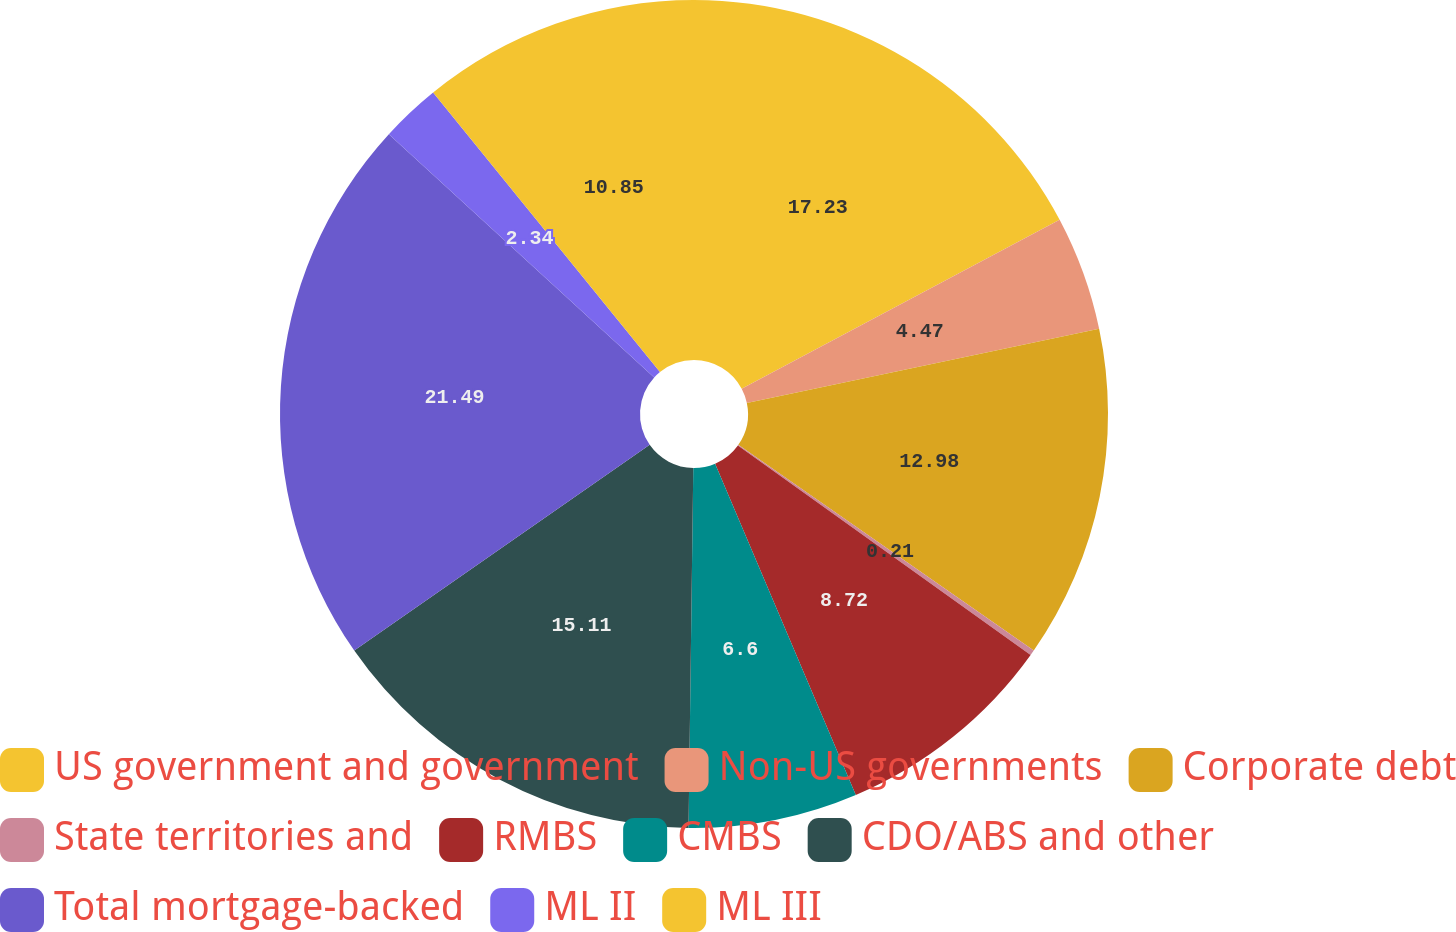<chart> <loc_0><loc_0><loc_500><loc_500><pie_chart><fcel>US government and government<fcel>Non-US governments<fcel>Corporate debt<fcel>State territories and<fcel>RMBS<fcel>CMBS<fcel>CDO/ABS and other<fcel>Total mortgage-backed<fcel>ML II<fcel>ML III<nl><fcel>17.23%<fcel>4.47%<fcel>12.98%<fcel>0.21%<fcel>8.72%<fcel>6.6%<fcel>15.11%<fcel>21.49%<fcel>2.34%<fcel>10.85%<nl></chart> 